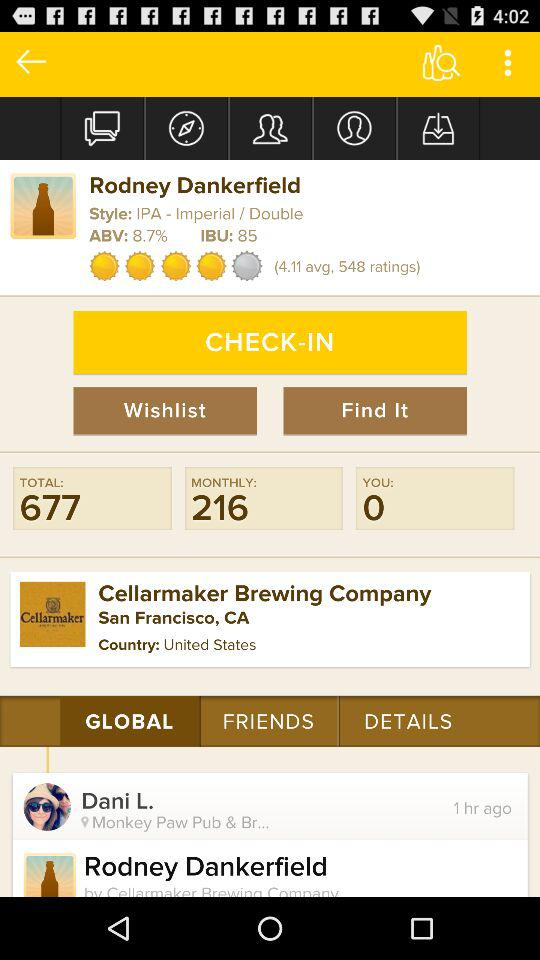How many ratings does "Rodney Dankerfield" have? It has 548 ratings. 